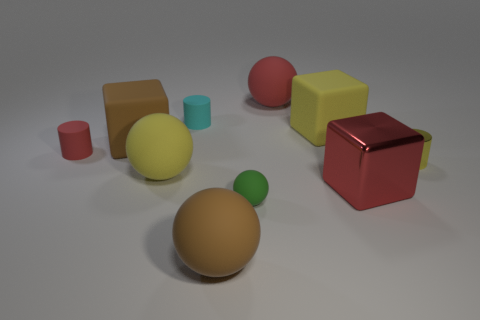Is the tiny red cylinder made of the same material as the cyan thing on the left side of the big metal thing?
Offer a terse response. Yes. How many green objects are large cubes or tiny metallic cubes?
Ensure brevity in your answer.  0. What is the size of the cyan cylinder that is the same material as the red cylinder?
Offer a terse response. Small. How many other red metallic things have the same shape as the large red metal thing?
Provide a succinct answer. 0. Is the number of big balls left of the big brown ball greater than the number of red cylinders that are on the right side of the metal cylinder?
Provide a succinct answer. Yes. Is the color of the shiny block the same as the rubber ball that is behind the red rubber cylinder?
Offer a very short reply. Yes. What material is the red block that is the same size as the yellow matte ball?
Provide a succinct answer. Metal. How many things are yellow shiny things or big objects that are behind the metallic cube?
Make the answer very short. 5. There is a brown ball; is its size the same as the yellow thing to the right of the yellow matte cube?
Offer a terse response. No. How many spheres are either small brown metal objects or tiny cyan things?
Your response must be concise. 0. 